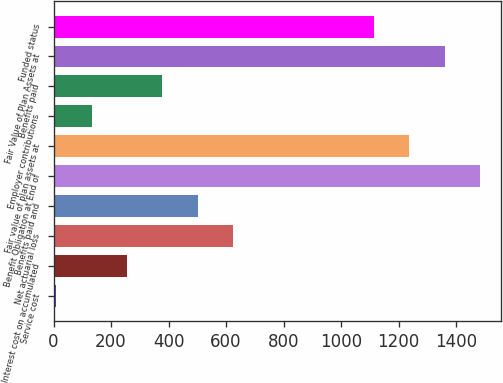Convert chart. <chart><loc_0><loc_0><loc_500><loc_500><bar_chart><fcel>Service cost<fcel>Interest cost on accumulated<fcel>Net actuarial loss<fcel>Benefits paid and<fcel>Benefit Obligation at End of<fcel>Fair value of plan assets at<fcel>Employer contributions<fcel>Benefits paid<fcel>Fair Value of Plan Assets at<fcel>Funded status<nl><fcel>10<fcel>255.6<fcel>624<fcel>501.2<fcel>1483.6<fcel>1238<fcel>132.8<fcel>378.4<fcel>1360.8<fcel>1115.2<nl></chart> 